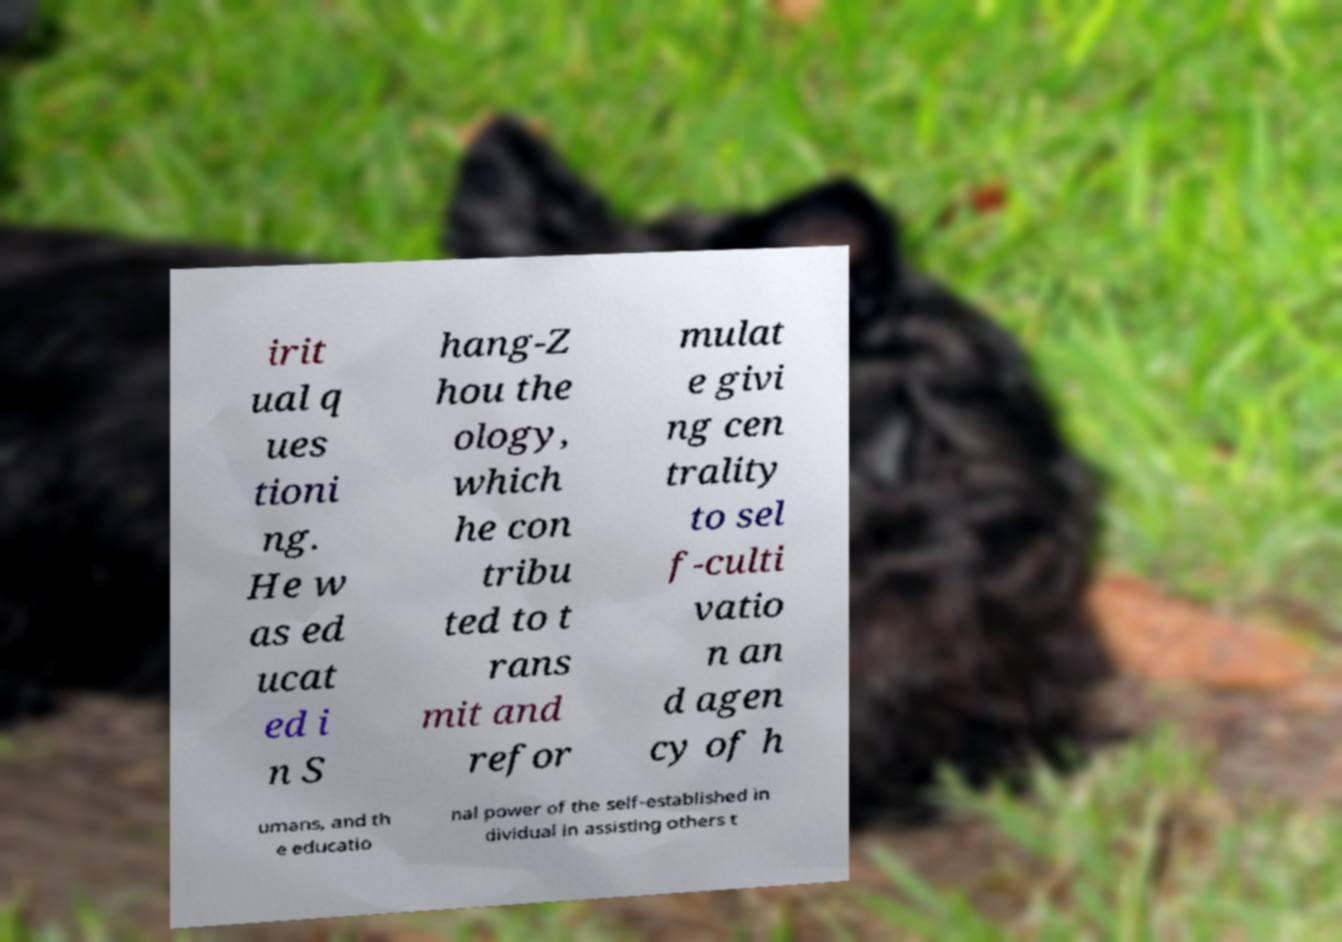For documentation purposes, I need the text within this image transcribed. Could you provide that? irit ual q ues tioni ng. He w as ed ucat ed i n S hang-Z hou the ology, which he con tribu ted to t rans mit and refor mulat e givi ng cen trality to sel f-culti vatio n an d agen cy of h umans, and th e educatio nal power of the self-established in dividual in assisting others t 